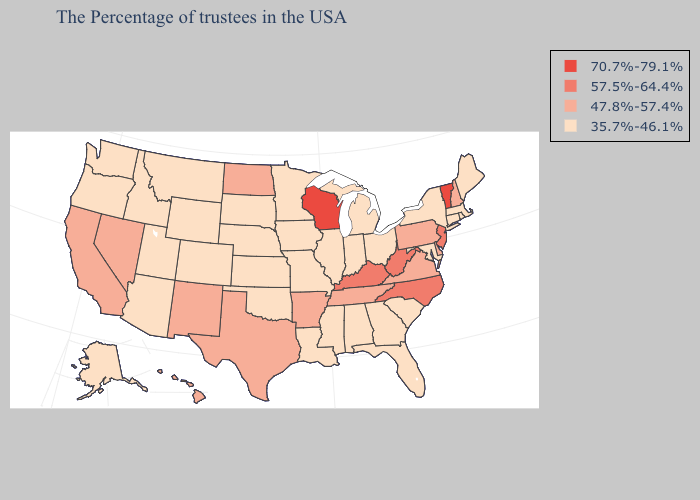What is the lowest value in states that border Mississippi?
Be succinct. 35.7%-46.1%. Name the states that have a value in the range 70.7%-79.1%?
Be succinct. Vermont, Wisconsin. What is the highest value in states that border Wyoming?
Answer briefly. 35.7%-46.1%. Name the states that have a value in the range 47.8%-57.4%?
Give a very brief answer. New Hampshire, Delaware, Pennsylvania, Virginia, Tennessee, Arkansas, Texas, North Dakota, New Mexico, Nevada, California, Hawaii. Does Maryland have the highest value in the USA?
Concise answer only. No. What is the lowest value in the Northeast?
Answer briefly. 35.7%-46.1%. Name the states that have a value in the range 47.8%-57.4%?
Answer briefly. New Hampshire, Delaware, Pennsylvania, Virginia, Tennessee, Arkansas, Texas, North Dakota, New Mexico, Nevada, California, Hawaii. How many symbols are there in the legend?
Give a very brief answer. 4. Does Idaho have the highest value in the West?
Short answer required. No. Does Georgia have the lowest value in the South?
Answer briefly. Yes. Which states have the lowest value in the USA?
Keep it brief. Maine, Massachusetts, Rhode Island, Connecticut, New York, Maryland, South Carolina, Ohio, Florida, Georgia, Michigan, Indiana, Alabama, Illinois, Mississippi, Louisiana, Missouri, Minnesota, Iowa, Kansas, Nebraska, Oklahoma, South Dakota, Wyoming, Colorado, Utah, Montana, Arizona, Idaho, Washington, Oregon, Alaska. Among the states that border Massachusetts , which have the highest value?
Short answer required. Vermont. What is the lowest value in the USA?
Give a very brief answer. 35.7%-46.1%. Which states have the lowest value in the USA?
Answer briefly. Maine, Massachusetts, Rhode Island, Connecticut, New York, Maryland, South Carolina, Ohio, Florida, Georgia, Michigan, Indiana, Alabama, Illinois, Mississippi, Louisiana, Missouri, Minnesota, Iowa, Kansas, Nebraska, Oklahoma, South Dakota, Wyoming, Colorado, Utah, Montana, Arizona, Idaho, Washington, Oregon, Alaska. Name the states that have a value in the range 47.8%-57.4%?
Give a very brief answer. New Hampshire, Delaware, Pennsylvania, Virginia, Tennessee, Arkansas, Texas, North Dakota, New Mexico, Nevada, California, Hawaii. 